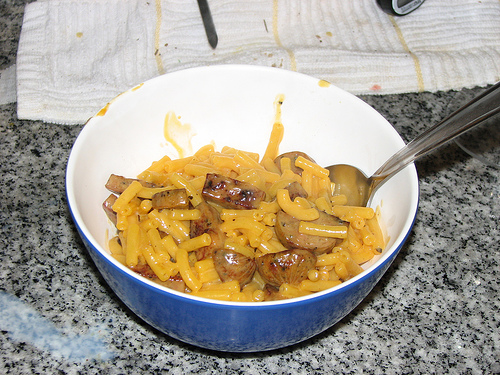<image>
Is there a spoon next to the bowl? No. The spoon is not positioned next to the bowl. They are located in different areas of the scene. Is there a sausage in the macaroni? Yes. The sausage is contained within or inside the macaroni, showing a containment relationship. 